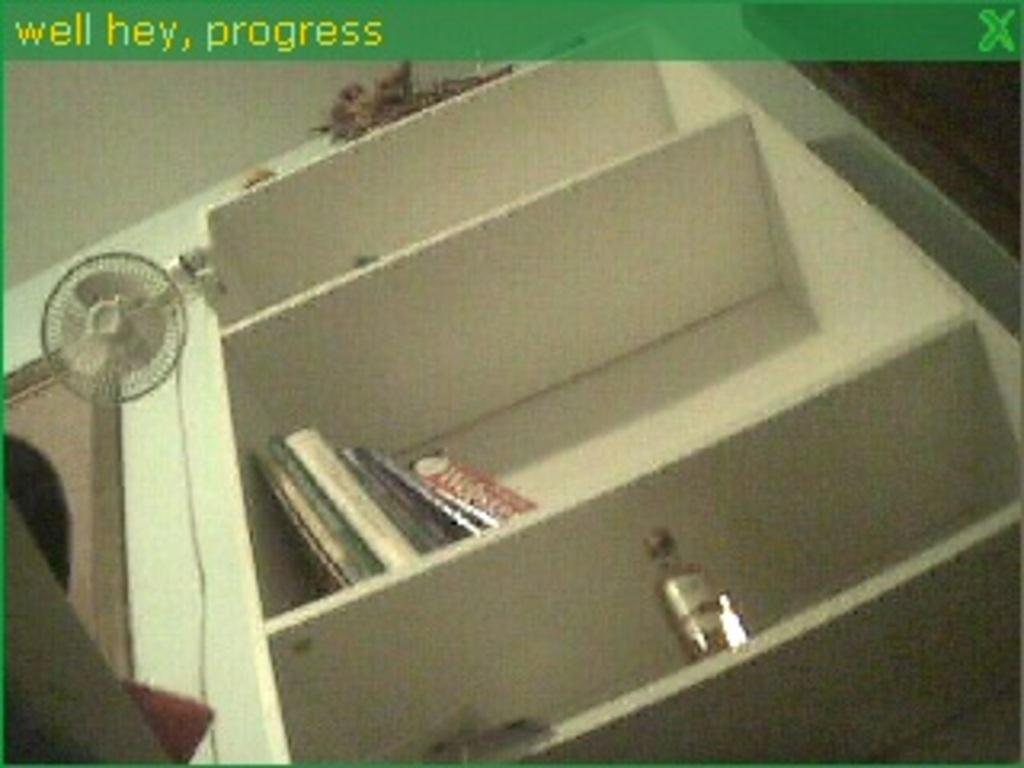What is on the rack in the image? There is a rack with books and a bottle in the image. Can you describe the fan in the image? There is a fan attached to the wall in the image. What is above the rack in the image? There appears to be an object above the rack in the image. Is there any indication of the image's origin or source? Yes, there is a watermark on the image. Can you tell me how many animals are visible in the zoo in the image? There is no zoo or animals present in the image; it features a rack with books and a bottle, a fan attached to the wall, and an object above the rack. What type of metal is used to construct the rack in the image? The image does not provide information about the material used to construct the rack, so it cannot be determined from the image. 